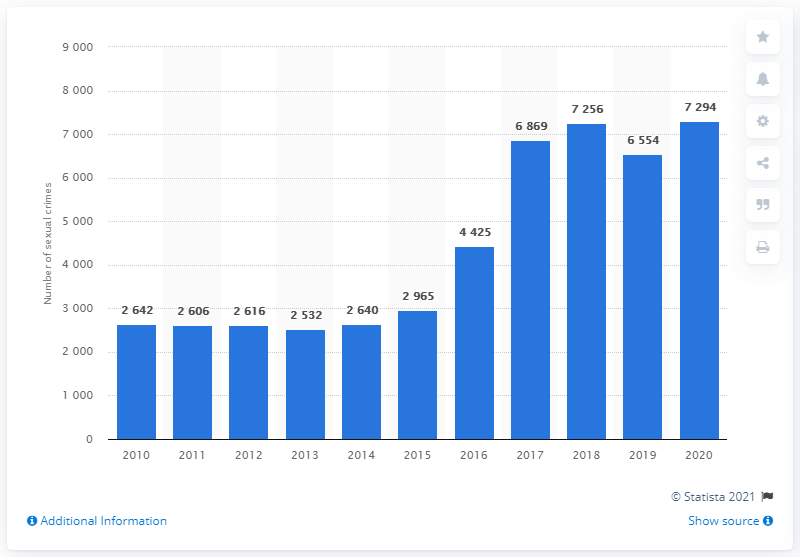How many sexual crimes were reported in Denmark in 2020?
 7294 